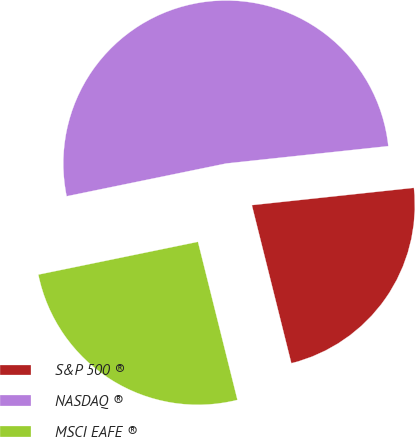Convert chart to OTSL. <chart><loc_0><loc_0><loc_500><loc_500><pie_chart><fcel>S&P 500 ®<fcel>NASDAQ ®<fcel>MSCI EAFE ®<nl><fcel>22.8%<fcel>51.53%<fcel>25.67%<nl></chart> 